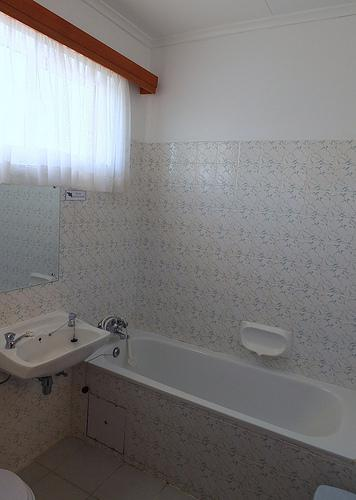Question: where is this location?
Choices:
A. The kitchen.
B. A bathroom.
C. The living room.
D. The bedroom.
Answer with the letter. Answer: B Question: where is the toilet?
Choices:
A. The bottom left corner.
B. Next to the bathtub.
C. In the far back corner of the room.
D. Next to the sink.
Answer with the letter. Answer: A Question: how is the glass on the wall?
Choices:
A. Taped to wall.
B. Screwed on wall.
C. Glued to wall.
D. Painted onto the wall.
Answer with the letter. Answer: B Question: what is below the tub?
Choices:
A. A removable floorboard.
B. A loose tile.
C. A tiny compartment.
D. The drain pipe.
Answer with the letter. Answer: C Question: what is on the wall?
Choices:
A. A painting.
B. A clock.
C. A mirror and sink.
D. A towel hanger.
Answer with the letter. Answer: C 